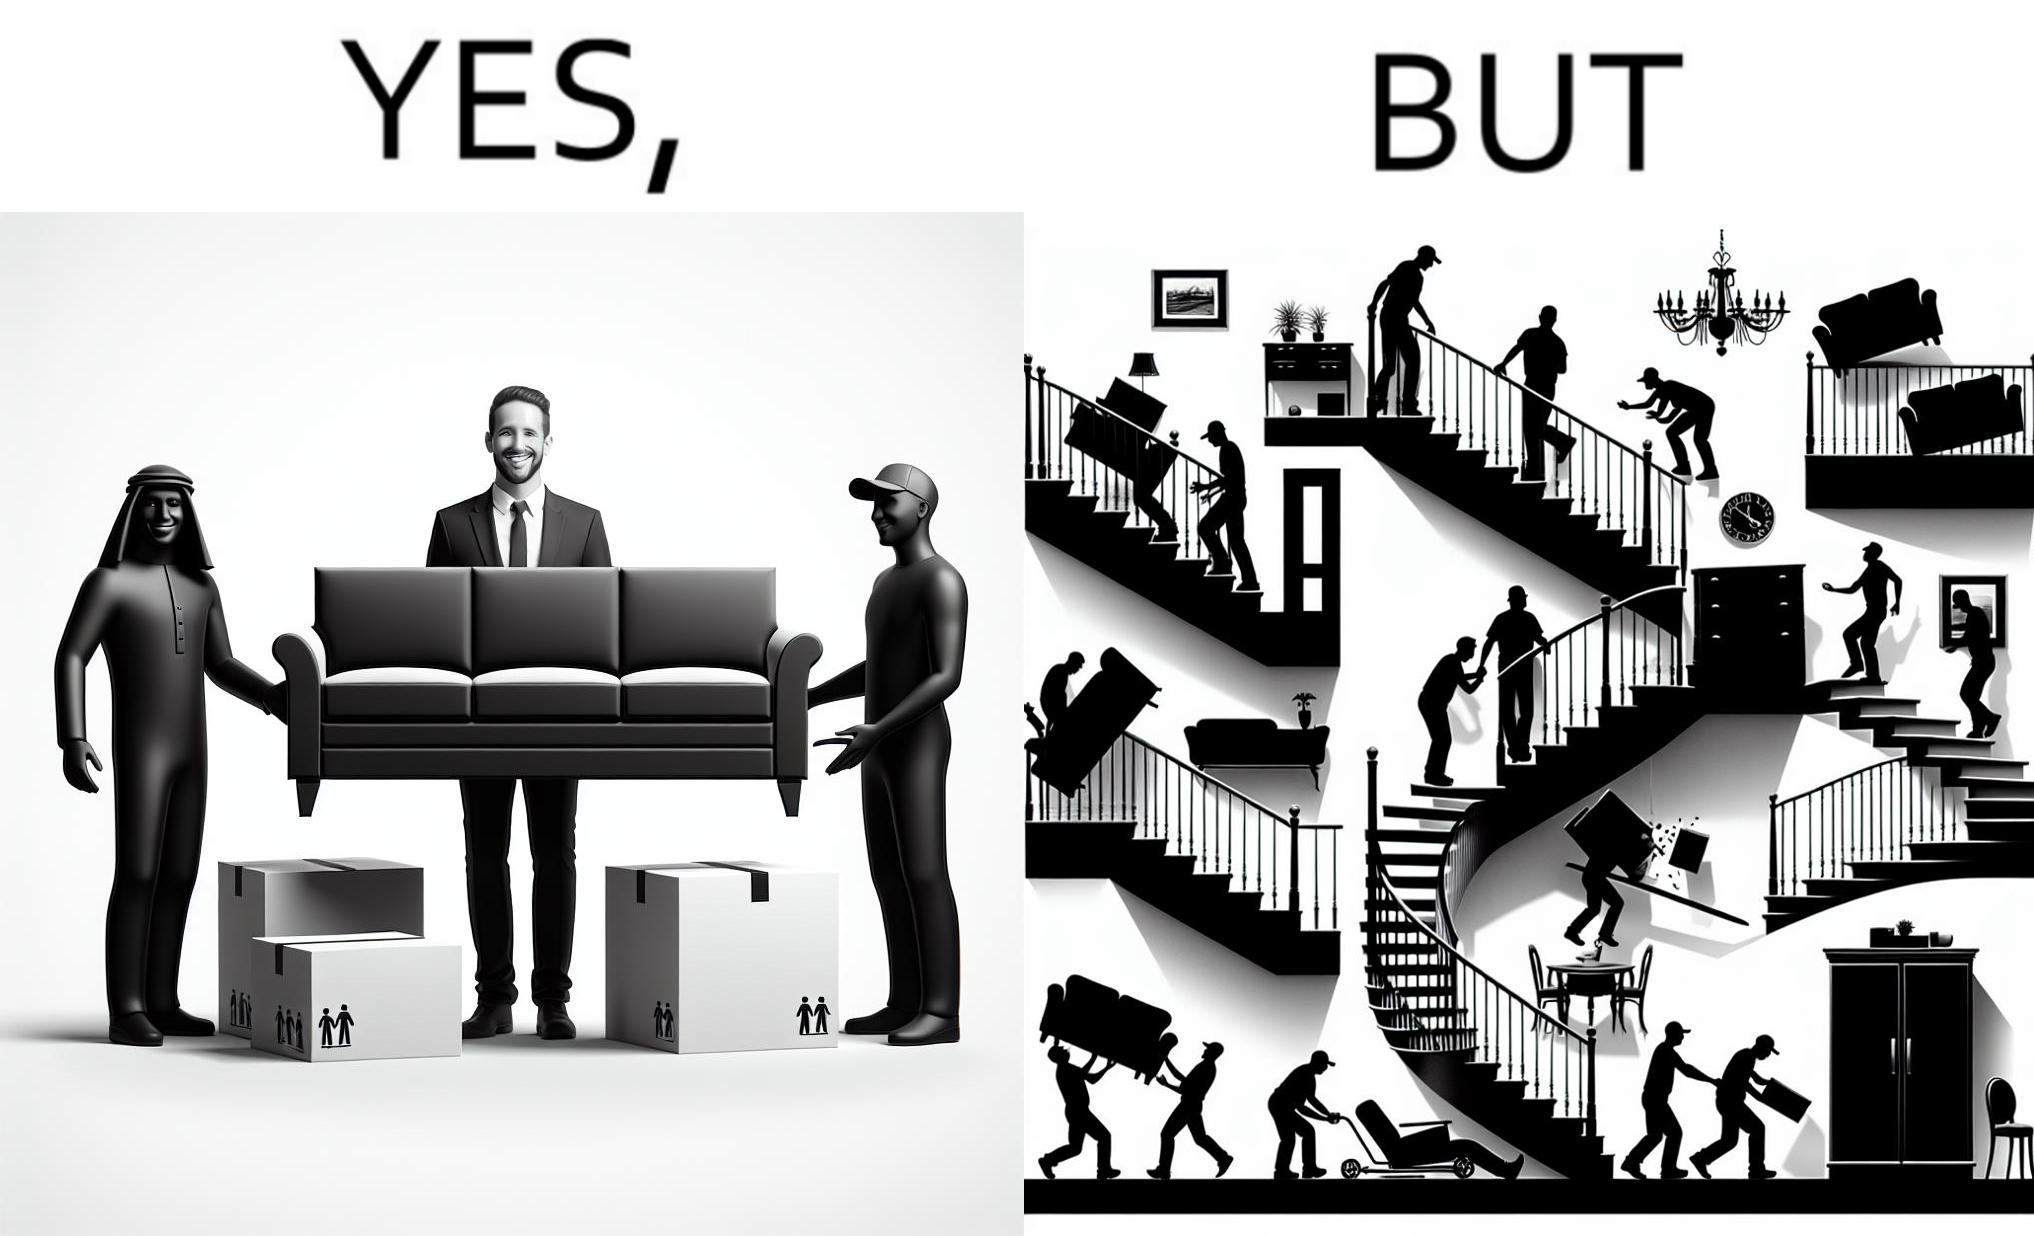Describe the contrast between the left and right parts of this image. In the left part of the image: A man happy with movers who have helped move in a sofa In the right part of the image: Images show how movers have damaged a house while moving in furniture 